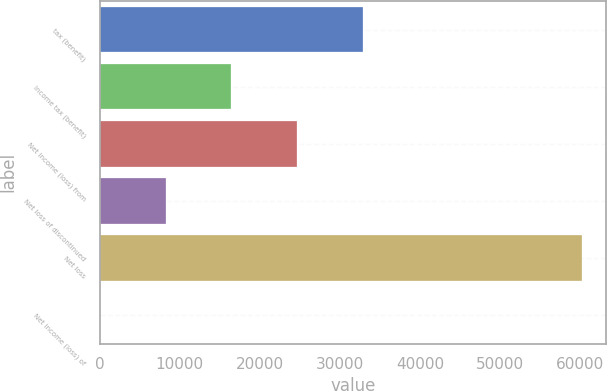Convert chart. <chart><loc_0><loc_0><loc_500><loc_500><bar_chart><fcel>tax (benefit)<fcel>Income tax (benefit)<fcel>Net income (loss) from<fcel>Net loss of discontinued<fcel>Net loss<fcel>Net income (loss) of<nl><fcel>32878.4<fcel>16439.2<fcel>24658.8<fcel>8219.66<fcel>60252<fcel>0.07<nl></chart> 